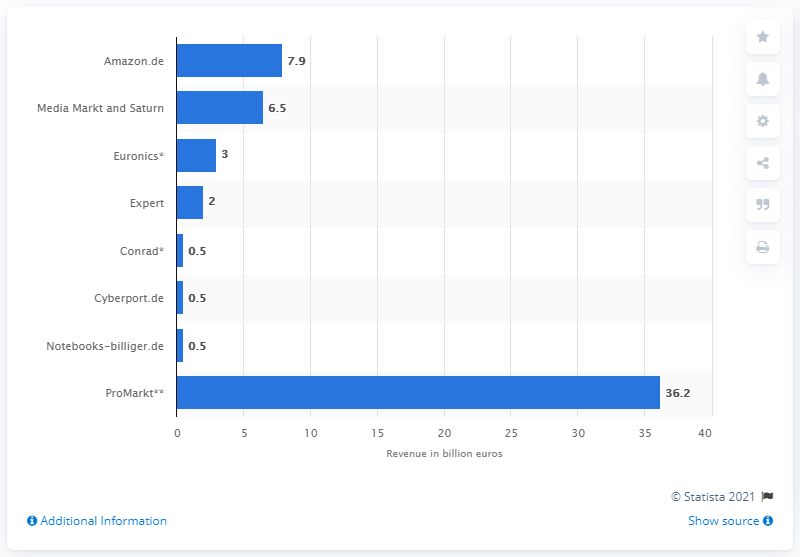Identify some key points in this picture. In 2013, the revenue of Media Markt and Saturn was 6.5 billion euros. In 2013, Amazon.de's revenue was 7.9 billion euros. 